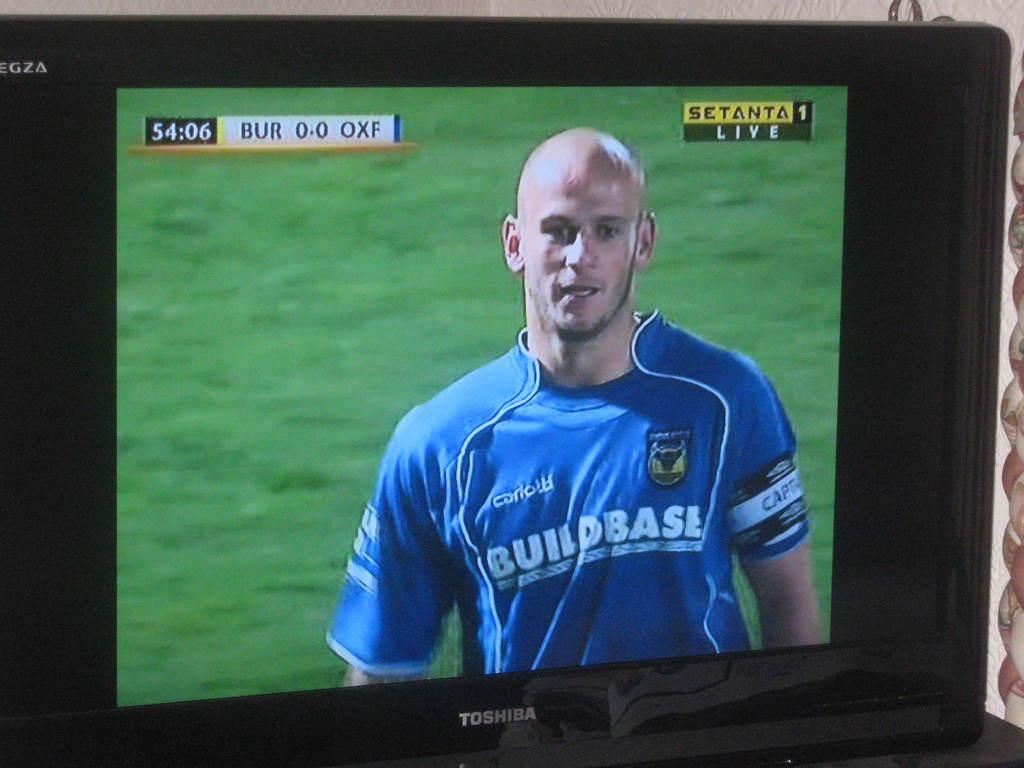<image>
Present a compact description of the photo's key features. A man in a uniform is on a monitor that says Toshiba. 